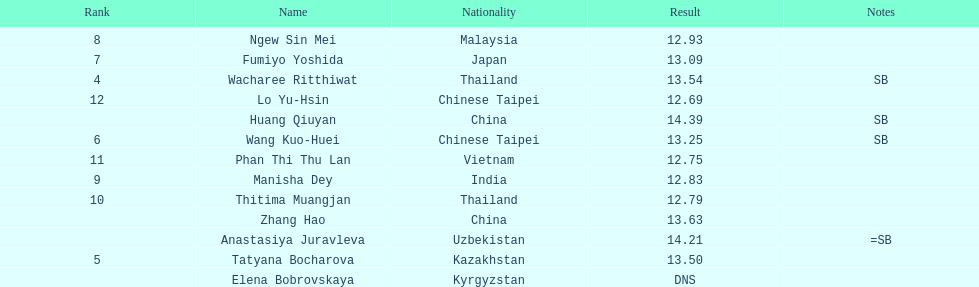Which country had the most competitors ranked in the top three in the event? China. 